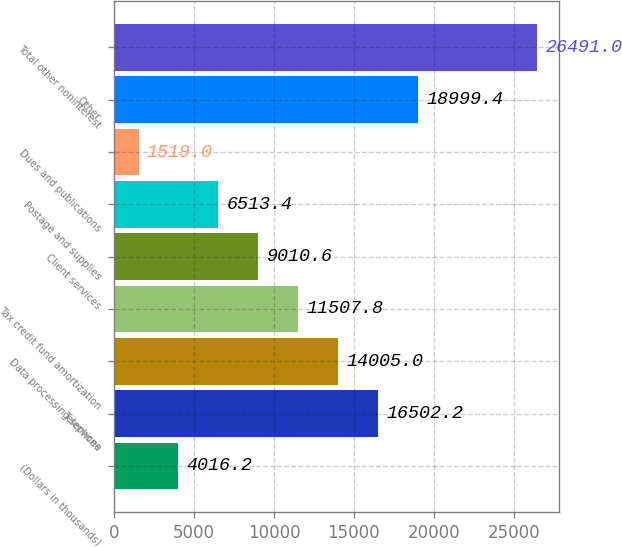<chart> <loc_0><loc_0><loc_500><loc_500><bar_chart><fcel>(Dollars in thousands)<fcel>Telephone<fcel>Data processing services<fcel>Tax credit fund amortization<fcel>Client services<fcel>Postage and supplies<fcel>Dues and publications<fcel>Other<fcel>Total other noninterest<nl><fcel>4016.2<fcel>16502.2<fcel>14005<fcel>11507.8<fcel>9010.6<fcel>6513.4<fcel>1519<fcel>18999.4<fcel>26491<nl></chart> 